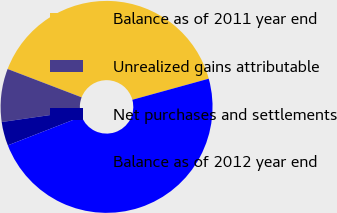Convert chart. <chart><loc_0><loc_0><loc_500><loc_500><pie_chart><fcel>Balance as of 2011 year end<fcel>Unrealized gains attributable<fcel>Net purchases and settlements<fcel>Balance as of 2012 year end<nl><fcel>39.9%<fcel>8.1%<fcel>3.63%<fcel>48.37%<nl></chart> 